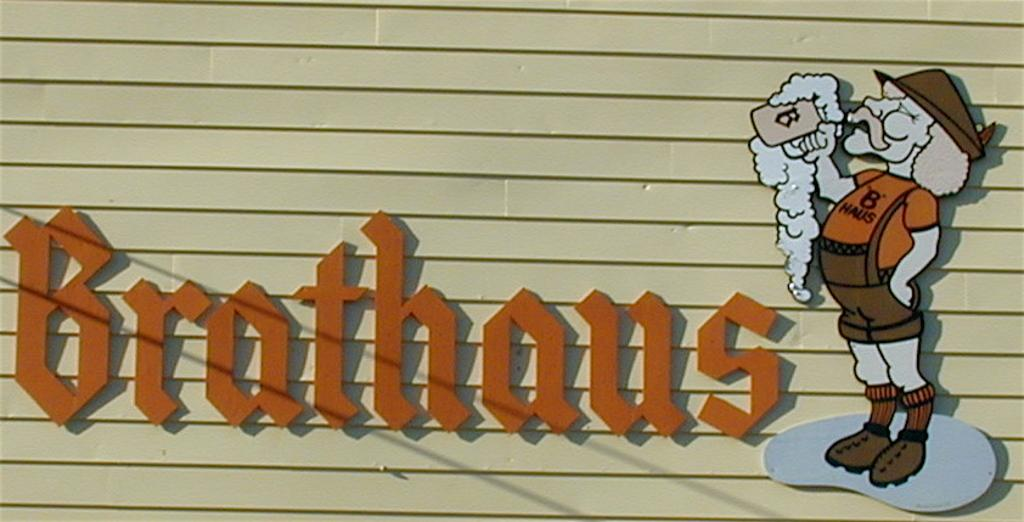What is present on the wall in the image? There is a picture of a person on the right side of the wall and some text in the middle of the wall. Can you describe the picture of the person on the wall? Unfortunately, the details of the person's image cannot be determined from the provided facts. What does the text on the wall say? The content of the text on the wall cannot be determined from the provided facts. How many birds are in the flock that is flying over the wall in the image? There is no flock of birds present in the image; it only features a wall with a picture of a person and some text. What type of wrench is being used to adjust the number on the wall in the image? There is no wrench or number present in the image; it only features a wall with a picture of a person and some text. 